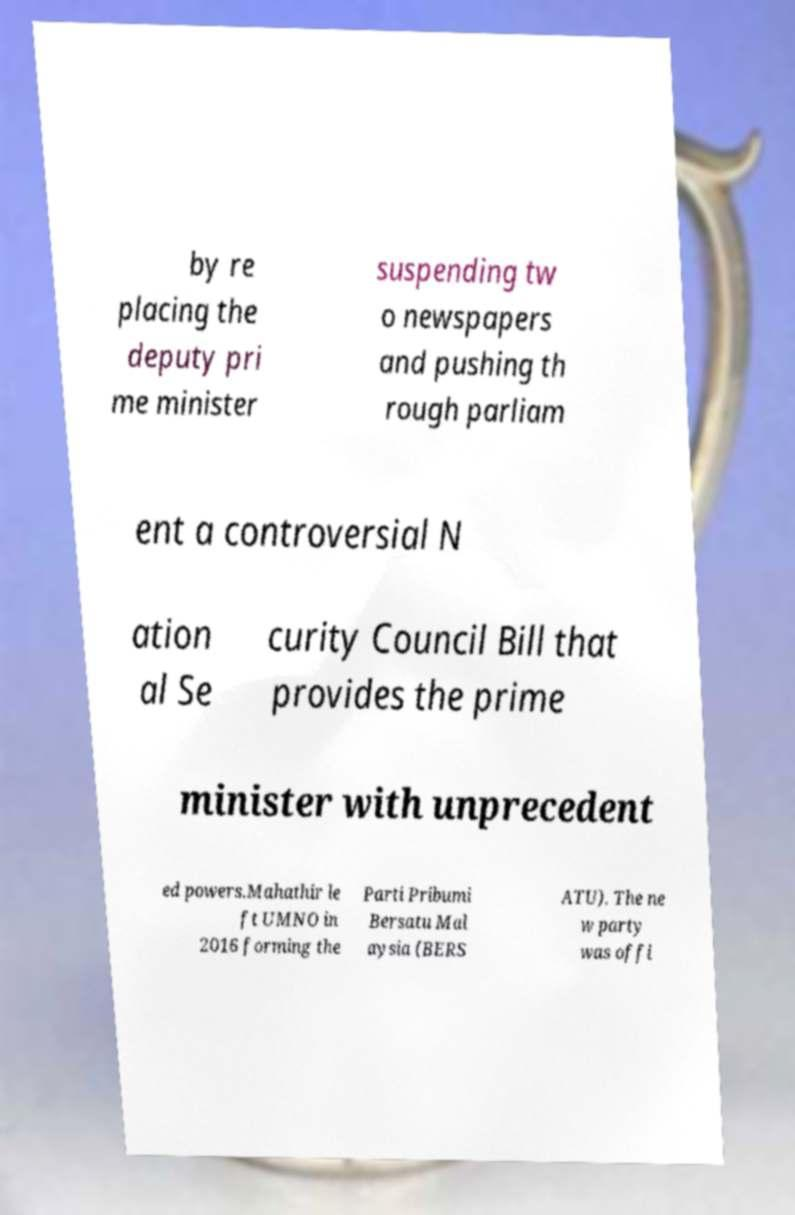For documentation purposes, I need the text within this image transcribed. Could you provide that? by re placing the deputy pri me minister suspending tw o newspapers and pushing th rough parliam ent a controversial N ation al Se curity Council Bill that provides the prime minister with unprecedent ed powers.Mahathir le ft UMNO in 2016 forming the Parti Pribumi Bersatu Mal aysia (BERS ATU). The ne w party was offi 